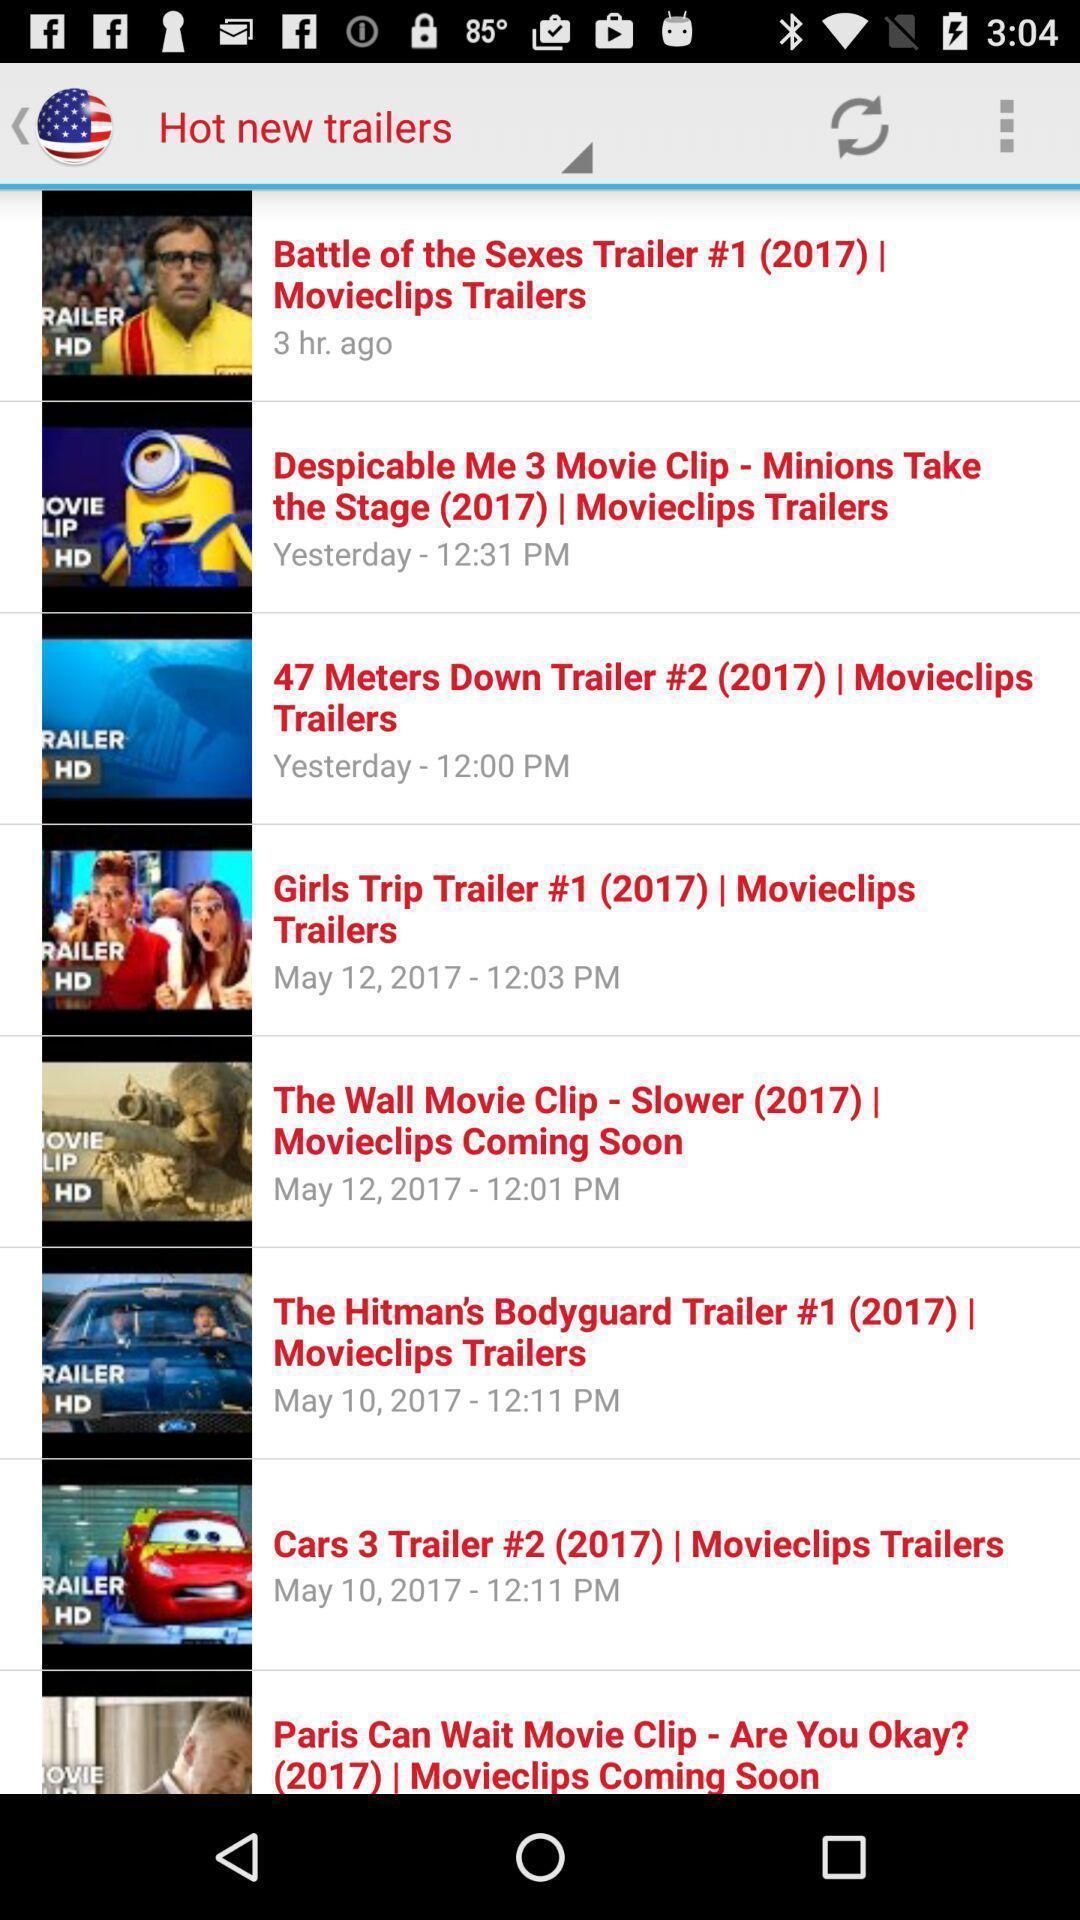What details can you identify in this image? Screen display list of various new trailers. 